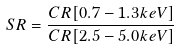Convert formula to latex. <formula><loc_0><loc_0><loc_500><loc_500>S R = \frac { C R [ 0 . 7 - 1 . 3 k e V ] } { C R [ 2 . 5 - 5 . 0 k e V ] }</formula> 